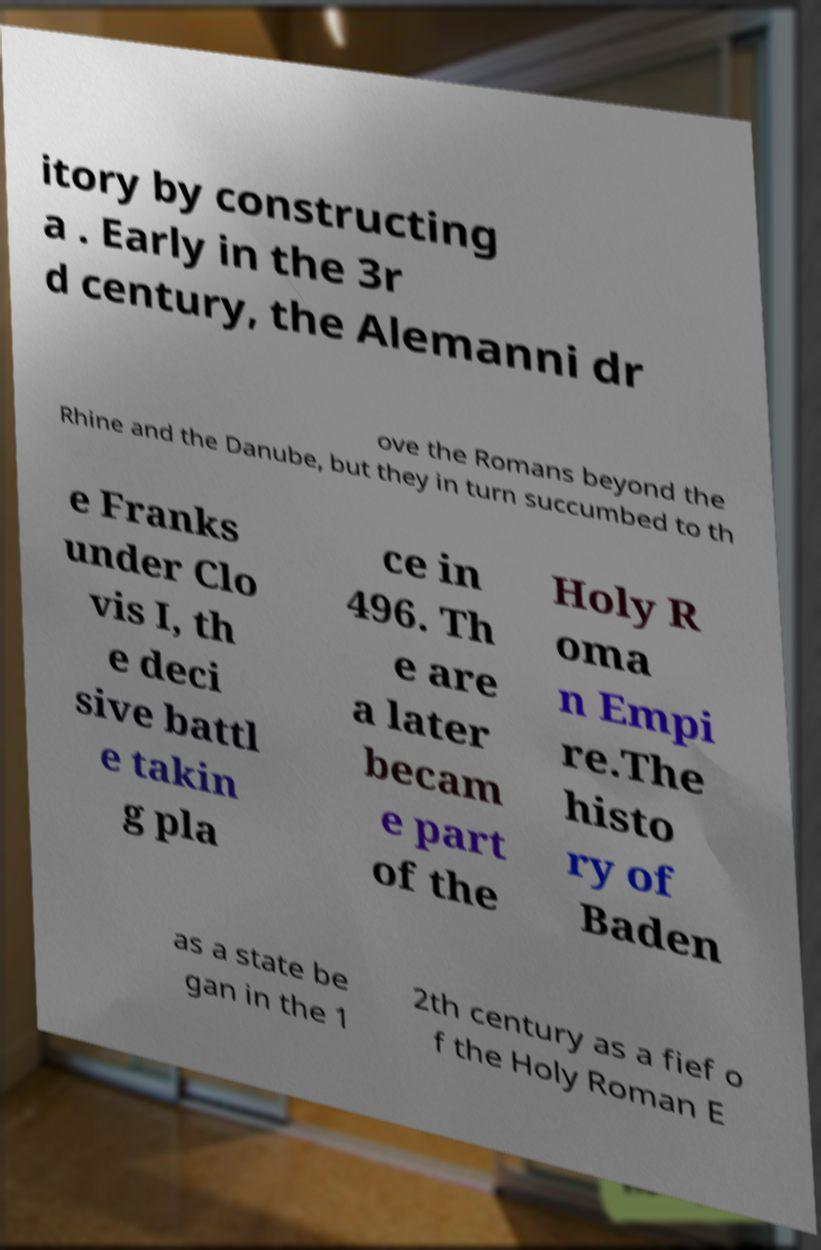I need the written content from this picture converted into text. Can you do that? itory by constructing a . Early in the 3r d century, the Alemanni dr ove the Romans beyond the Rhine and the Danube, but they in turn succumbed to th e Franks under Clo vis I, th e deci sive battl e takin g pla ce in 496. Th e are a later becam e part of the Holy R oma n Empi re.The histo ry of Baden as a state be gan in the 1 2th century as a fief o f the Holy Roman E 